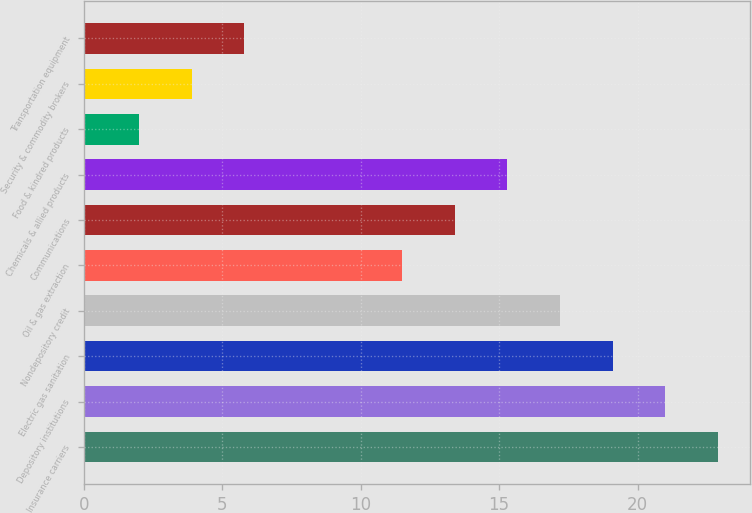Convert chart to OTSL. <chart><loc_0><loc_0><loc_500><loc_500><bar_chart><fcel>Insurance carriers<fcel>Depository institutions<fcel>Electric gas sanitation<fcel>Nondepository credit<fcel>Oil & gas extraction<fcel>Communications<fcel>Chemicals & allied products<fcel>Food & kindred products<fcel>Security & commodity brokers<fcel>Transportation equipment<nl><fcel>22.9<fcel>21<fcel>19.1<fcel>17.2<fcel>11.5<fcel>13.4<fcel>15.3<fcel>2<fcel>3.9<fcel>5.8<nl></chart> 